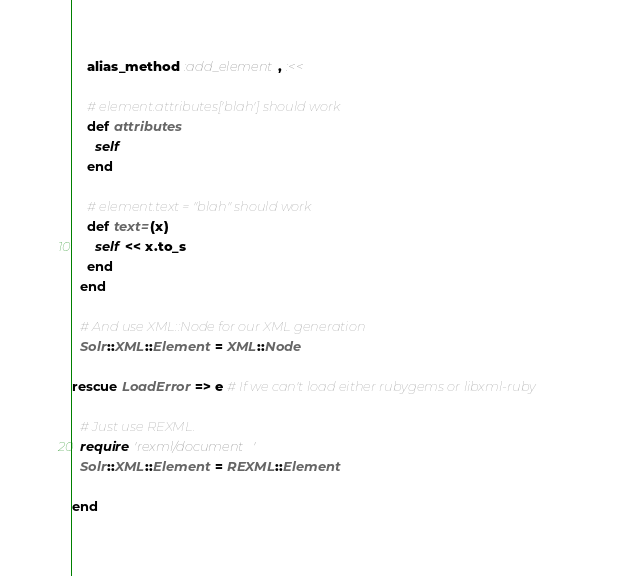Convert code to text. <code><loc_0><loc_0><loc_500><loc_500><_Ruby_>    alias_method :add_element, :<<

    # element.attributes['blah'] should work
    def attributes
      self
    end

    # element.text = "blah" should work
    def text=(x)
      self << x.to_s
    end
  end
  
  # And use XML::Node for our XML generation
  Solr::XML::Element = XML::Node
  
rescue LoadError => e # If we can't load either rubygems or libxml-ruby
  
  # Just use REXML.
  require 'rexml/document'
  Solr::XML::Element = REXML::Element
  
end</code> 